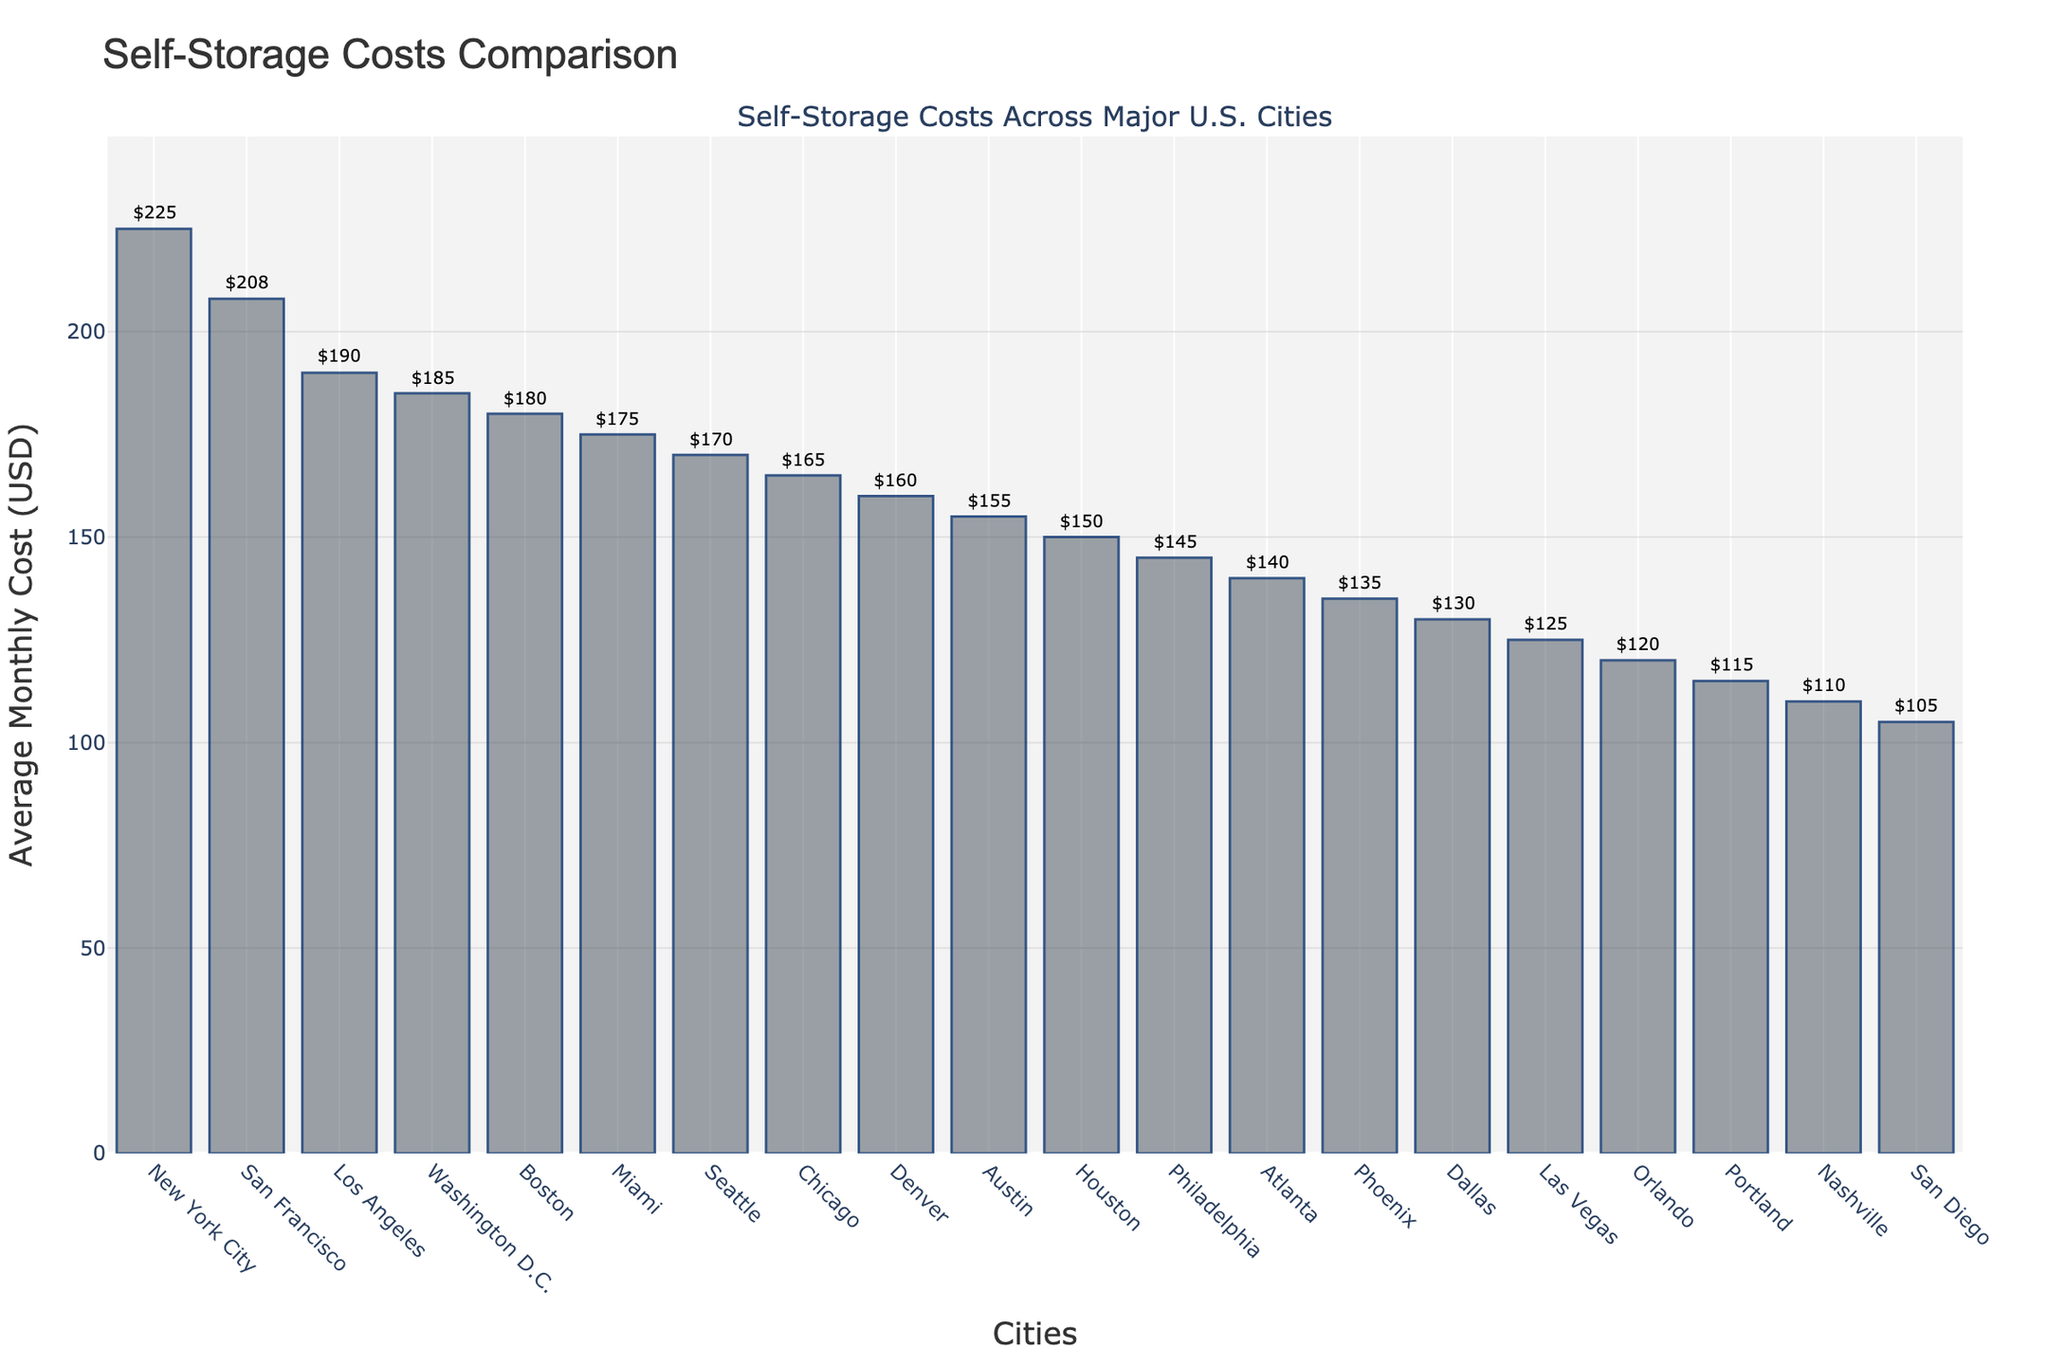What is the average monthly cost of self-storage in New York City? The average monthly cost for New York City can be directly read from the corresponding bar on the chart, which is labeled with the cost value.
Answer: $225 Which city has the lowest average monthly cost for self-storage? The city with the lowest average monthly cost will have the shortest bar on the chart. By inspecting the height of the bars, we find that San Diego has the lowest one.
Answer: San Diego How much more does self-storage cost on average in New York City compared to Las Vegas? First, identify the costs for New York City and Las Vegas from the chart ($225 and $125, respectively). Then subtract the two values: $225 - $125.
Answer: $100 Which cities have an average monthly cost less than $150? Identify the bars with heights corresponding to costs less than $150. These are Houston, Philadelphia, Atlanta, Phoenix, Dallas, Las Vegas, Orlando, Portland, Nashville, and San Diego.
Answer: Houston, Philadelphia, Atlanta, Phoenix, Dallas, Las Vegas, Orlando, Portland, Nashville, San Diego How many cities have an average monthly cost higher than $180? Count the cities with bars higher than the $180 mark. These are New York City, San Francisco, Los Angeles, Washington D.C., and Boston. There are 5 cities.
Answer: 5 What is the difference between the highest and the lowest average monthly costs? Identify the highest and lowest costs from the chart, which are $225 (New York City) and $105 (San Diego), respectively, then compute the difference: $225 - $105.
Answer: $120 Is the average monthly cost of self-storage in Boston more or less than in Miami? Compare the heights of the bars representing Boston and Miami. Boston has a cost of $180 and Miami has $175. Since $180 is more than $175, Boston is more expensive.
Answer: More What is the total average monthly cost for self-storage in the top three most expensive cities? Identify the top three cities (New York City $225, San Francisco $208, Los Angeles $190) and sum their costs: $225 + $208 + $190.
Answer: $623 